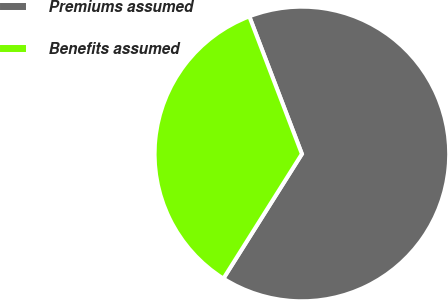Convert chart to OTSL. <chart><loc_0><loc_0><loc_500><loc_500><pie_chart><fcel>Premiums assumed<fcel>Benefits assumed<nl><fcel>64.76%<fcel>35.24%<nl></chart> 